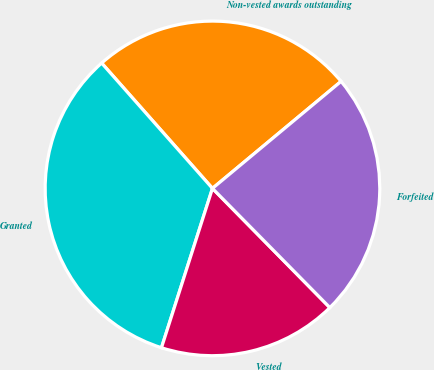Convert chart to OTSL. <chart><loc_0><loc_0><loc_500><loc_500><pie_chart><fcel>Non-vested awards outstanding<fcel>Granted<fcel>Vested<fcel>Forfeited<nl><fcel>25.48%<fcel>33.55%<fcel>17.31%<fcel>23.67%<nl></chart> 